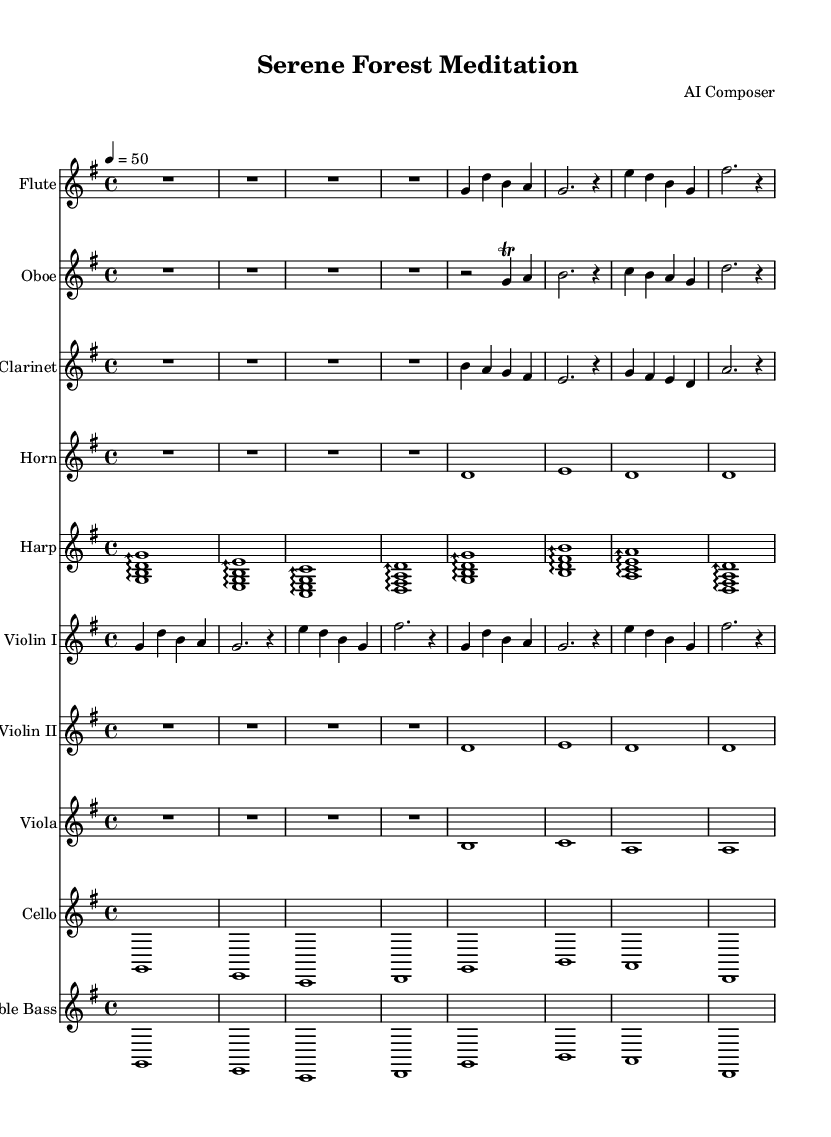What is the key signature of this music? The key signature is G major, which has one sharp (F#). This can be determined by looking at the clef and the key signature indicated at the beginning of the score.
Answer: G major What is the time signature of this music? The time signature is 4/4, indicated at the beginning of the score. It suggests that there are four beats in a measure and a quarter note gets one beat.
Answer: 4/4 What is the tempo marking of this music? The tempo marking is 50 beats per minute, as indicated in the score. This dictates the speed at which the music should be played.
Answer: 50 Which instruments are included in this symphony? The symphony includes flute, oboe, clarinet, horn, harp, violins I and II, viola, cello, and double bass. This can be confirmed by looking at the staff for each instrument listed at the beginning of the score.
Answer: Flute, oboe, clarinet, horn, harp, violins I and II, viola, cello, double bass How many measures are in the first flute part? The first flute part contains four measures. To find this, you can count the vertical lines on the staff, which separate each measure.
Answer: Four measures Which instrument plays the longest note value in the opening section? The horn plays the longest note value in the opening section, as it holds whole notes throughout this part. The assessment can be made by examining the note values written on the horn's staff.
Answer: Horn 